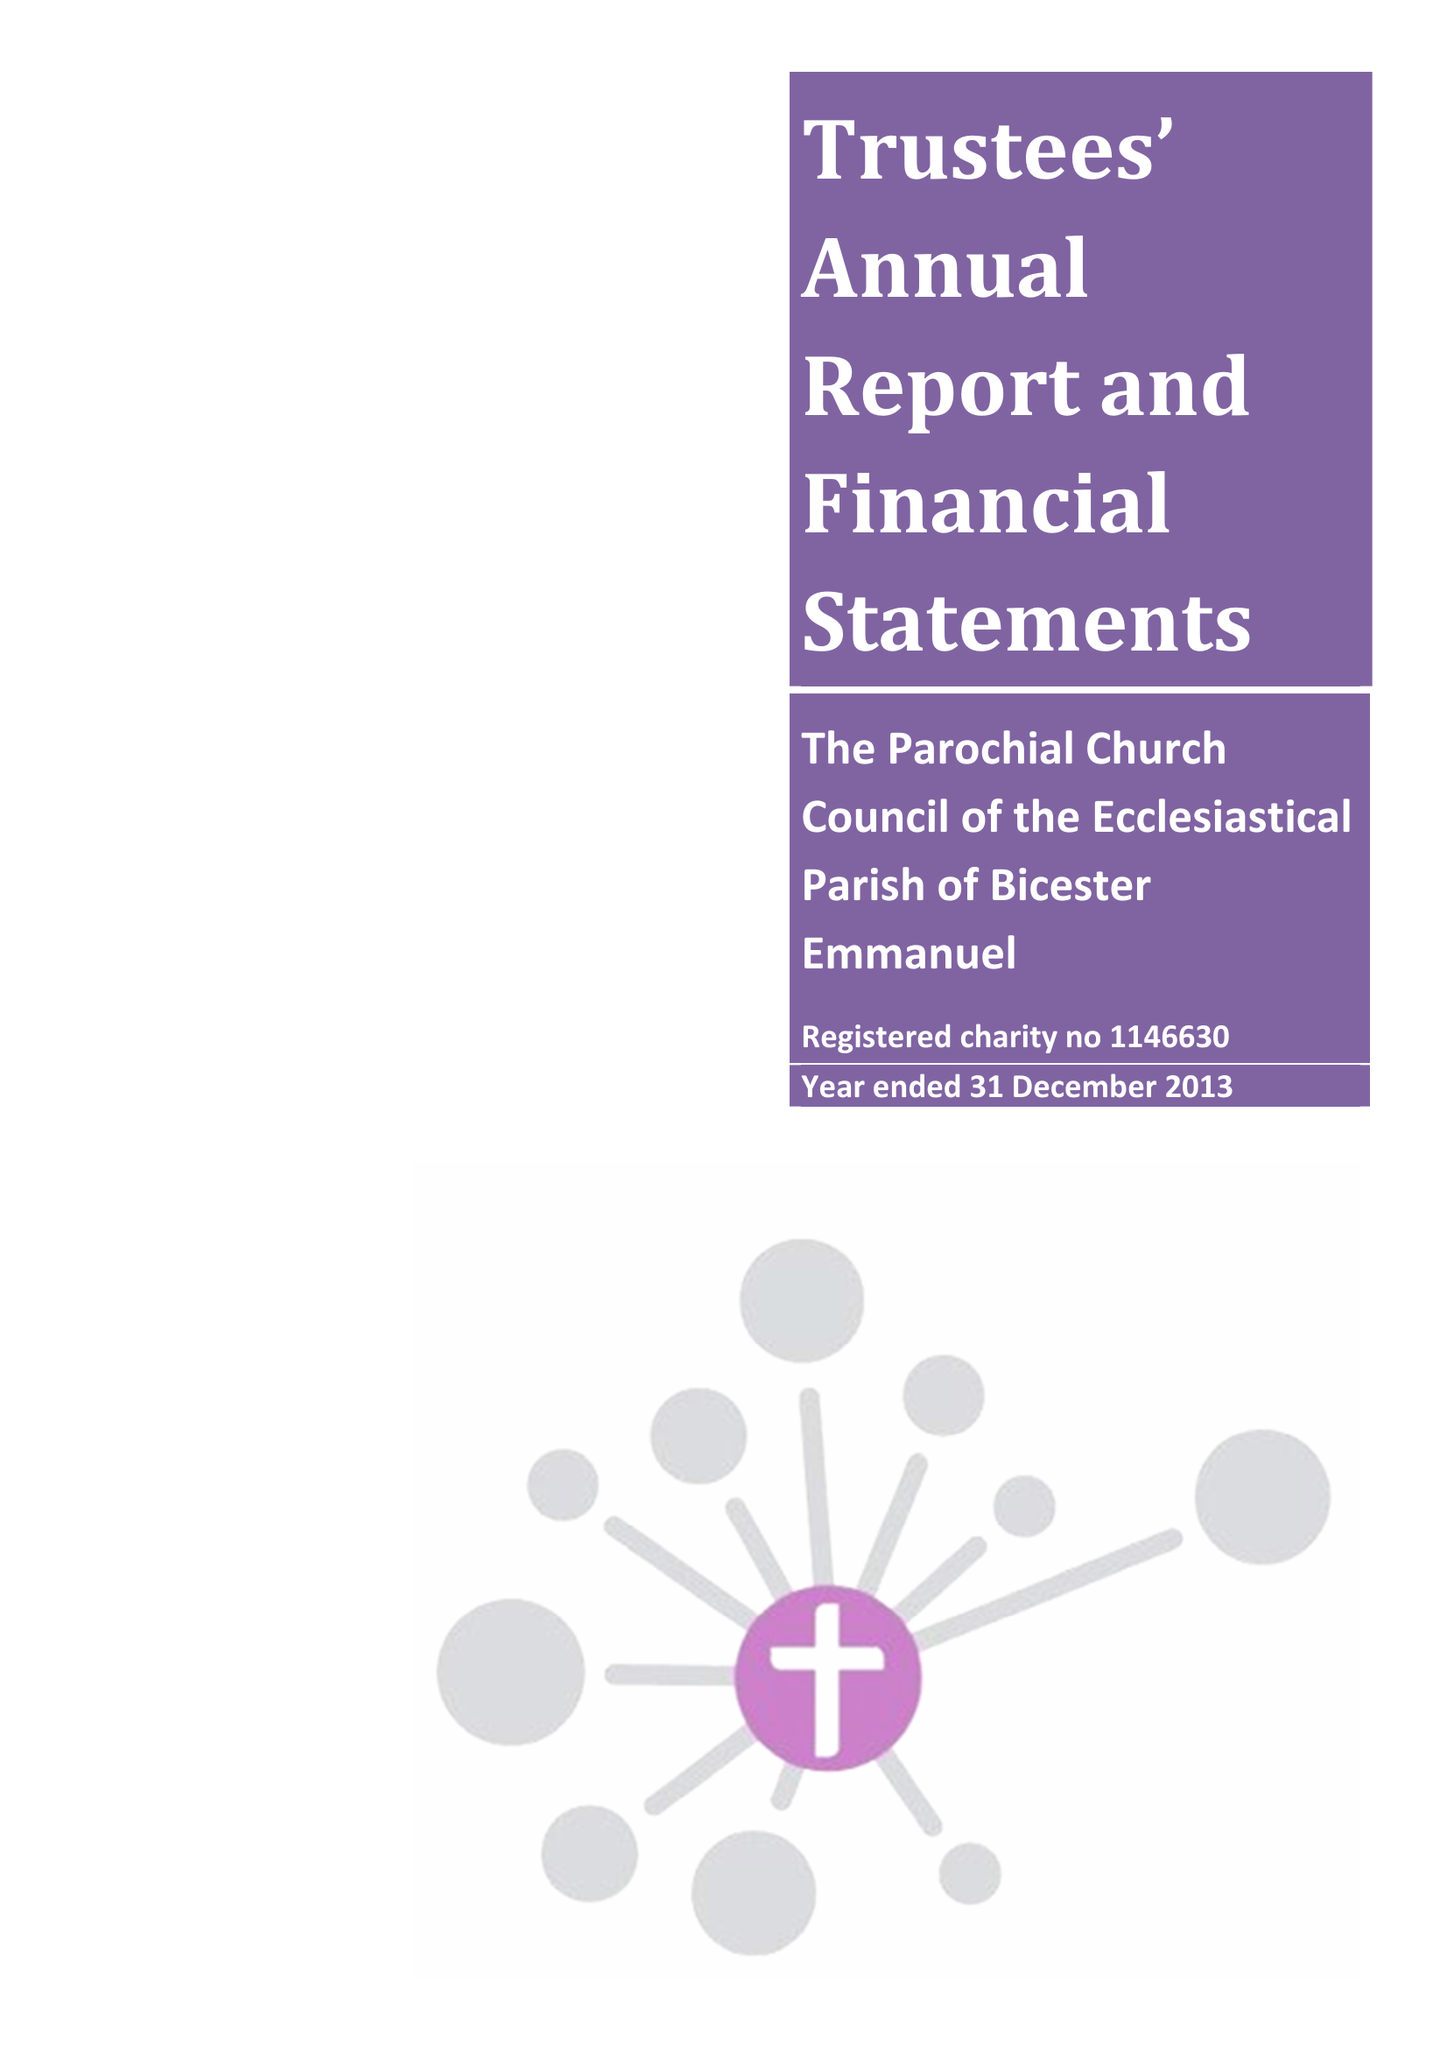What is the value for the income_annually_in_british_pounds?
Answer the question using a single word or phrase. 167704.00 